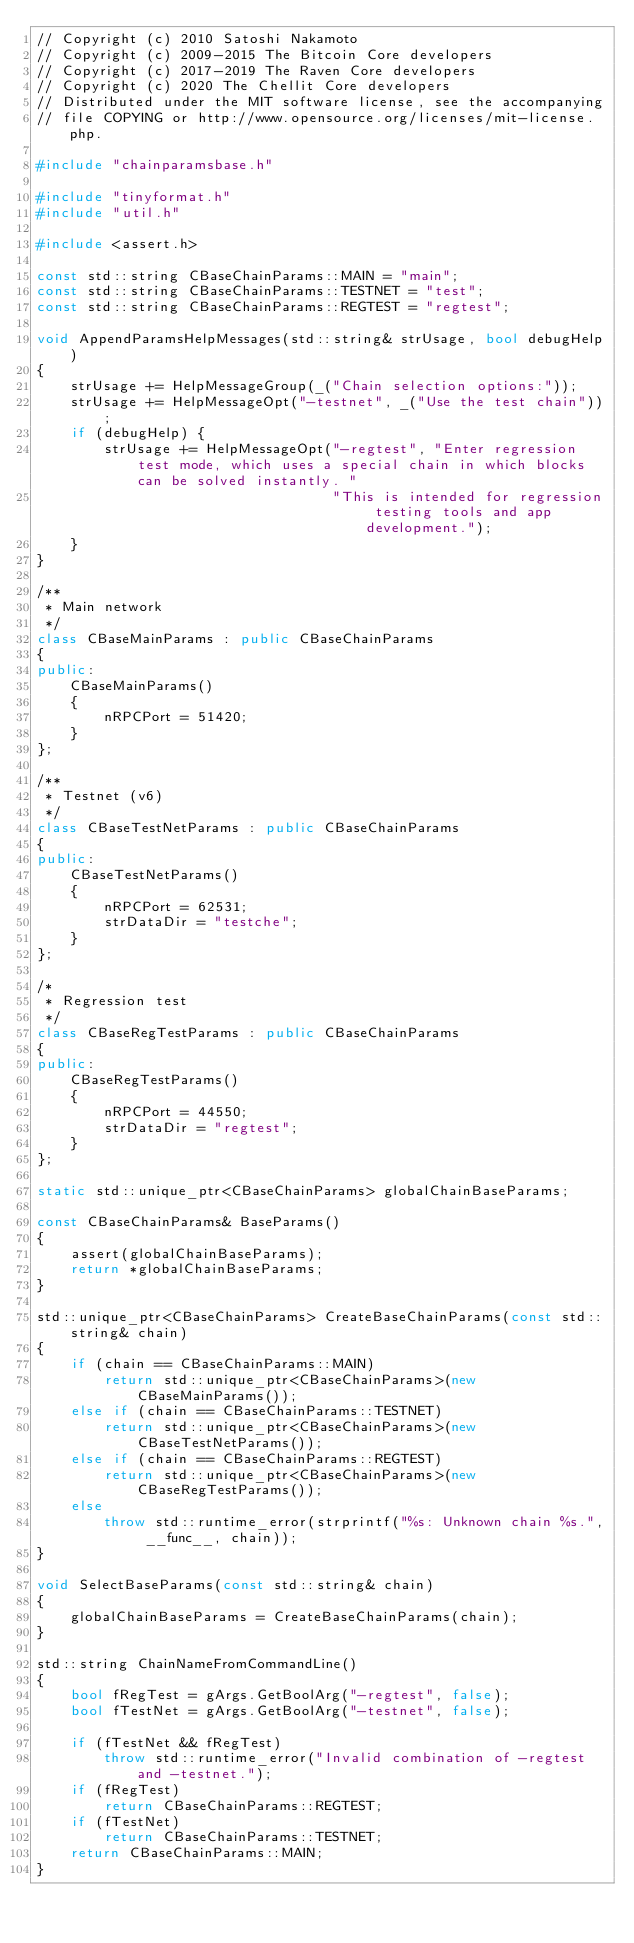<code> <loc_0><loc_0><loc_500><loc_500><_C++_>// Copyright (c) 2010 Satoshi Nakamoto
// Copyright (c) 2009-2015 The Bitcoin Core developers
// Copyright (c) 2017-2019 The Raven Core developers
// Copyright (c) 2020 The Chellit Core developers
// Distributed under the MIT software license, see the accompanying
// file COPYING or http://www.opensource.org/licenses/mit-license.php.

#include "chainparamsbase.h"

#include "tinyformat.h"
#include "util.h"

#include <assert.h>

const std::string CBaseChainParams::MAIN = "main";
const std::string CBaseChainParams::TESTNET = "test";
const std::string CBaseChainParams::REGTEST = "regtest";

void AppendParamsHelpMessages(std::string& strUsage, bool debugHelp)
{
    strUsage += HelpMessageGroup(_("Chain selection options:"));
    strUsage += HelpMessageOpt("-testnet", _("Use the test chain"));
    if (debugHelp) {
        strUsage += HelpMessageOpt("-regtest", "Enter regression test mode, which uses a special chain in which blocks can be solved instantly. "
                                   "This is intended for regression testing tools and app development.");
    }
}

/**
 * Main network
 */
class CBaseMainParams : public CBaseChainParams
{
public:
    CBaseMainParams()
    {
        nRPCPort = 51420;
    }
};

/**
 * Testnet (v6)
 */
class CBaseTestNetParams : public CBaseChainParams
{
public:
    CBaseTestNetParams()
    {
        nRPCPort = 62531;
        strDataDir = "testche";
    }
};

/*
 * Regression test
 */
class CBaseRegTestParams : public CBaseChainParams
{
public:
    CBaseRegTestParams()
    {
        nRPCPort = 44550;
        strDataDir = "regtest";
    }
};

static std::unique_ptr<CBaseChainParams> globalChainBaseParams;

const CBaseChainParams& BaseParams()
{
    assert(globalChainBaseParams);
    return *globalChainBaseParams;
}

std::unique_ptr<CBaseChainParams> CreateBaseChainParams(const std::string& chain)
{
    if (chain == CBaseChainParams::MAIN)
        return std::unique_ptr<CBaseChainParams>(new CBaseMainParams());
    else if (chain == CBaseChainParams::TESTNET)
        return std::unique_ptr<CBaseChainParams>(new CBaseTestNetParams());
    else if (chain == CBaseChainParams::REGTEST)
        return std::unique_ptr<CBaseChainParams>(new CBaseRegTestParams());
    else
        throw std::runtime_error(strprintf("%s: Unknown chain %s.", __func__, chain));
}

void SelectBaseParams(const std::string& chain)
{
    globalChainBaseParams = CreateBaseChainParams(chain);
}

std::string ChainNameFromCommandLine()
{
    bool fRegTest = gArgs.GetBoolArg("-regtest", false);
    bool fTestNet = gArgs.GetBoolArg("-testnet", false);

    if (fTestNet && fRegTest)
        throw std::runtime_error("Invalid combination of -regtest and -testnet.");
    if (fRegTest)
        return CBaseChainParams::REGTEST;
    if (fTestNet)
        return CBaseChainParams::TESTNET;
    return CBaseChainParams::MAIN;
}
</code> 